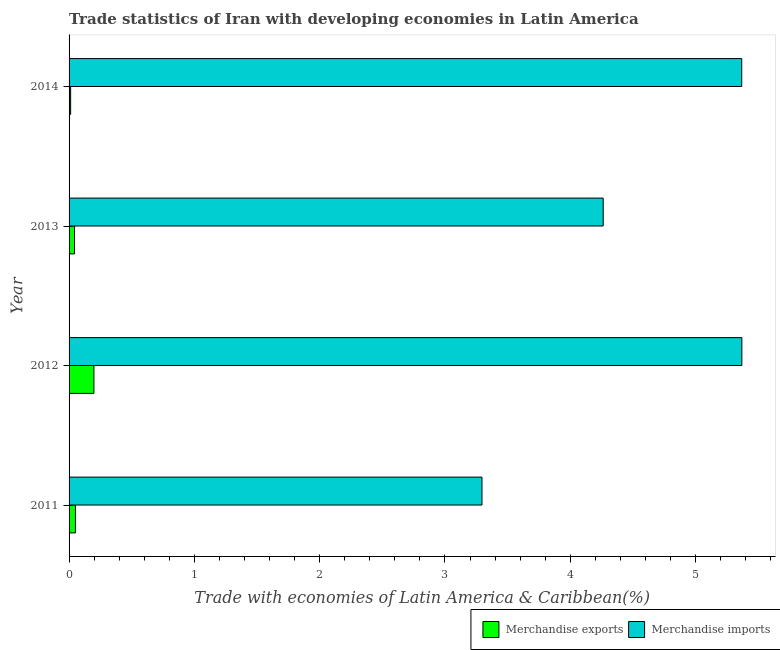How many different coloured bars are there?
Provide a succinct answer. 2. How many groups of bars are there?
Offer a terse response. 4. How many bars are there on the 2nd tick from the top?
Keep it short and to the point. 2. What is the merchandise exports in 2014?
Provide a short and direct response. 0.01. Across all years, what is the maximum merchandise exports?
Provide a short and direct response. 0.2. Across all years, what is the minimum merchandise exports?
Offer a terse response. 0.01. What is the total merchandise exports in the graph?
Make the answer very short. 0.31. What is the difference between the merchandise imports in 2013 and that in 2014?
Offer a terse response. -1.11. What is the difference between the merchandise exports in 2011 and the merchandise imports in 2012?
Offer a very short reply. -5.32. What is the average merchandise imports per year?
Keep it short and to the point. 4.57. In the year 2011, what is the difference between the merchandise exports and merchandise imports?
Your answer should be very brief. -3.24. In how many years, is the merchandise exports greater than 2.8 %?
Your answer should be compact. 0. What is the ratio of the merchandise exports in 2011 to that in 2014?
Make the answer very short. 4.08. Is the difference between the merchandise imports in 2011 and 2012 greater than the difference between the merchandise exports in 2011 and 2012?
Your answer should be compact. No. What is the difference between the highest and the second highest merchandise exports?
Make the answer very short. 0.15. What is the difference between the highest and the lowest merchandise imports?
Keep it short and to the point. 2.07. Is the sum of the merchandise imports in 2011 and 2013 greater than the maximum merchandise exports across all years?
Keep it short and to the point. Yes. What does the 1st bar from the bottom in 2012 represents?
Provide a succinct answer. Merchandise exports. How many bars are there?
Provide a succinct answer. 8. Are all the bars in the graph horizontal?
Make the answer very short. Yes. How many years are there in the graph?
Give a very brief answer. 4. What is the difference between two consecutive major ticks on the X-axis?
Provide a short and direct response. 1. Are the values on the major ticks of X-axis written in scientific E-notation?
Make the answer very short. No. Does the graph contain grids?
Offer a very short reply. No. How many legend labels are there?
Your response must be concise. 2. What is the title of the graph?
Ensure brevity in your answer.  Trade statistics of Iran with developing economies in Latin America. What is the label or title of the X-axis?
Keep it short and to the point. Trade with economies of Latin America & Caribbean(%). What is the label or title of the Y-axis?
Provide a succinct answer. Year. What is the Trade with economies of Latin America & Caribbean(%) of Merchandise exports in 2011?
Your answer should be very brief. 0.05. What is the Trade with economies of Latin America & Caribbean(%) of Merchandise imports in 2011?
Offer a terse response. 3.3. What is the Trade with economies of Latin America & Caribbean(%) of Merchandise exports in 2012?
Provide a succinct answer. 0.2. What is the Trade with economies of Latin America & Caribbean(%) of Merchandise imports in 2012?
Give a very brief answer. 5.37. What is the Trade with economies of Latin America & Caribbean(%) in Merchandise exports in 2013?
Keep it short and to the point. 0.04. What is the Trade with economies of Latin America & Caribbean(%) in Merchandise imports in 2013?
Ensure brevity in your answer.  4.26. What is the Trade with economies of Latin America & Caribbean(%) in Merchandise exports in 2014?
Make the answer very short. 0.01. What is the Trade with economies of Latin America & Caribbean(%) of Merchandise imports in 2014?
Make the answer very short. 5.37. Across all years, what is the maximum Trade with economies of Latin America & Caribbean(%) of Merchandise exports?
Your response must be concise. 0.2. Across all years, what is the maximum Trade with economies of Latin America & Caribbean(%) in Merchandise imports?
Provide a short and direct response. 5.37. Across all years, what is the minimum Trade with economies of Latin America & Caribbean(%) in Merchandise exports?
Your answer should be very brief. 0.01. Across all years, what is the minimum Trade with economies of Latin America & Caribbean(%) of Merchandise imports?
Offer a terse response. 3.3. What is the total Trade with economies of Latin America & Caribbean(%) in Merchandise exports in the graph?
Provide a succinct answer. 0.31. What is the total Trade with economies of Latin America & Caribbean(%) in Merchandise imports in the graph?
Offer a very short reply. 18.3. What is the difference between the Trade with economies of Latin America & Caribbean(%) in Merchandise exports in 2011 and that in 2012?
Make the answer very short. -0.15. What is the difference between the Trade with economies of Latin America & Caribbean(%) in Merchandise imports in 2011 and that in 2012?
Give a very brief answer. -2.07. What is the difference between the Trade with economies of Latin America & Caribbean(%) of Merchandise exports in 2011 and that in 2013?
Your answer should be compact. 0.01. What is the difference between the Trade with economies of Latin America & Caribbean(%) of Merchandise imports in 2011 and that in 2013?
Your answer should be very brief. -0.97. What is the difference between the Trade with economies of Latin America & Caribbean(%) of Merchandise exports in 2011 and that in 2014?
Provide a short and direct response. 0.04. What is the difference between the Trade with economies of Latin America & Caribbean(%) in Merchandise imports in 2011 and that in 2014?
Make the answer very short. -2.07. What is the difference between the Trade with economies of Latin America & Caribbean(%) in Merchandise exports in 2012 and that in 2013?
Your answer should be very brief. 0.15. What is the difference between the Trade with economies of Latin America & Caribbean(%) of Merchandise imports in 2012 and that in 2013?
Offer a terse response. 1.11. What is the difference between the Trade with economies of Latin America & Caribbean(%) in Merchandise exports in 2012 and that in 2014?
Keep it short and to the point. 0.19. What is the difference between the Trade with economies of Latin America & Caribbean(%) in Merchandise exports in 2013 and that in 2014?
Offer a terse response. 0.03. What is the difference between the Trade with economies of Latin America & Caribbean(%) of Merchandise imports in 2013 and that in 2014?
Provide a short and direct response. -1.11. What is the difference between the Trade with economies of Latin America & Caribbean(%) of Merchandise exports in 2011 and the Trade with economies of Latin America & Caribbean(%) of Merchandise imports in 2012?
Offer a terse response. -5.32. What is the difference between the Trade with economies of Latin America & Caribbean(%) of Merchandise exports in 2011 and the Trade with economies of Latin America & Caribbean(%) of Merchandise imports in 2013?
Your answer should be compact. -4.21. What is the difference between the Trade with economies of Latin America & Caribbean(%) of Merchandise exports in 2011 and the Trade with economies of Latin America & Caribbean(%) of Merchandise imports in 2014?
Provide a succinct answer. -5.32. What is the difference between the Trade with economies of Latin America & Caribbean(%) of Merchandise exports in 2012 and the Trade with economies of Latin America & Caribbean(%) of Merchandise imports in 2013?
Your answer should be very brief. -4.06. What is the difference between the Trade with economies of Latin America & Caribbean(%) in Merchandise exports in 2012 and the Trade with economies of Latin America & Caribbean(%) in Merchandise imports in 2014?
Provide a succinct answer. -5.17. What is the difference between the Trade with economies of Latin America & Caribbean(%) in Merchandise exports in 2013 and the Trade with economies of Latin America & Caribbean(%) in Merchandise imports in 2014?
Provide a short and direct response. -5.32. What is the average Trade with economies of Latin America & Caribbean(%) of Merchandise exports per year?
Your response must be concise. 0.08. What is the average Trade with economies of Latin America & Caribbean(%) of Merchandise imports per year?
Make the answer very short. 4.57. In the year 2011, what is the difference between the Trade with economies of Latin America & Caribbean(%) in Merchandise exports and Trade with economies of Latin America & Caribbean(%) in Merchandise imports?
Your answer should be very brief. -3.24. In the year 2012, what is the difference between the Trade with economies of Latin America & Caribbean(%) in Merchandise exports and Trade with economies of Latin America & Caribbean(%) in Merchandise imports?
Provide a short and direct response. -5.17. In the year 2013, what is the difference between the Trade with economies of Latin America & Caribbean(%) of Merchandise exports and Trade with economies of Latin America & Caribbean(%) of Merchandise imports?
Your answer should be compact. -4.22. In the year 2014, what is the difference between the Trade with economies of Latin America & Caribbean(%) in Merchandise exports and Trade with economies of Latin America & Caribbean(%) in Merchandise imports?
Keep it short and to the point. -5.36. What is the ratio of the Trade with economies of Latin America & Caribbean(%) of Merchandise exports in 2011 to that in 2012?
Ensure brevity in your answer.  0.26. What is the ratio of the Trade with economies of Latin America & Caribbean(%) of Merchandise imports in 2011 to that in 2012?
Offer a terse response. 0.61. What is the ratio of the Trade with economies of Latin America & Caribbean(%) in Merchandise exports in 2011 to that in 2013?
Ensure brevity in your answer.  1.17. What is the ratio of the Trade with economies of Latin America & Caribbean(%) in Merchandise imports in 2011 to that in 2013?
Your answer should be compact. 0.77. What is the ratio of the Trade with economies of Latin America & Caribbean(%) in Merchandise exports in 2011 to that in 2014?
Make the answer very short. 4.08. What is the ratio of the Trade with economies of Latin America & Caribbean(%) in Merchandise imports in 2011 to that in 2014?
Your answer should be compact. 0.61. What is the ratio of the Trade with economies of Latin America & Caribbean(%) of Merchandise exports in 2012 to that in 2013?
Ensure brevity in your answer.  4.54. What is the ratio of the Trade with economies of Latin America & Caribbean(%) in Merchandise imports in 2012 to that in 2013?
Your answer should be very brief. 1.26. What is the ratio of the Trade with economies of Latin America & Caribbean(%) of Merchandise exports in 2012 to that in 2014?
Your response must be concise. 15.9. What is the ratio of the Trade with economies of Latin America & Caribbean(%) in Merchandise exports in 2013 to that in 2014?
Offer a very short reply. 3.5. What is the ratio of the Trade with economies of Latin America & Caribbean(%) in Merchandise imports in 2013 to that in 2014?
Ensure brevity in your answer.  0.79. What is the difference between the highest and the second highest Trade with economies of Latin America & Caribbean(%) in Merchandise exports?
Make the answer very short. 0.15. What is the difference between the highest and the lowest Trade with economies of Latin America & Caribbean(%) of Merchandise exports?
Provide a short and direct response. 0.19. What is the difference between the highest and the lowest Trade with economies of Latin America & Caribbean(%) in Merchandise imports?
Your response must be concise. 2.07. 